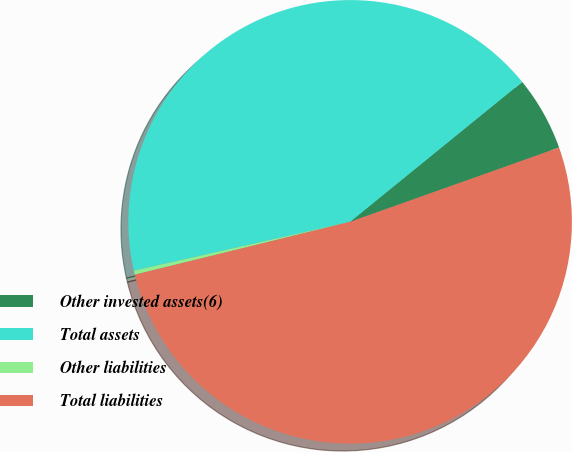Convert chart. <chart><loc_0><loc_0><loc_500><loc_500><pie_chart><fcel>Other invested assets(6)<fcel>Total assets<fcel>Other liabilities<fcel>Total liabilities<nl><fcel>5.43%<fcel>42.67%<fcel>0.3%<fcel>51.6%<nl></chart> 